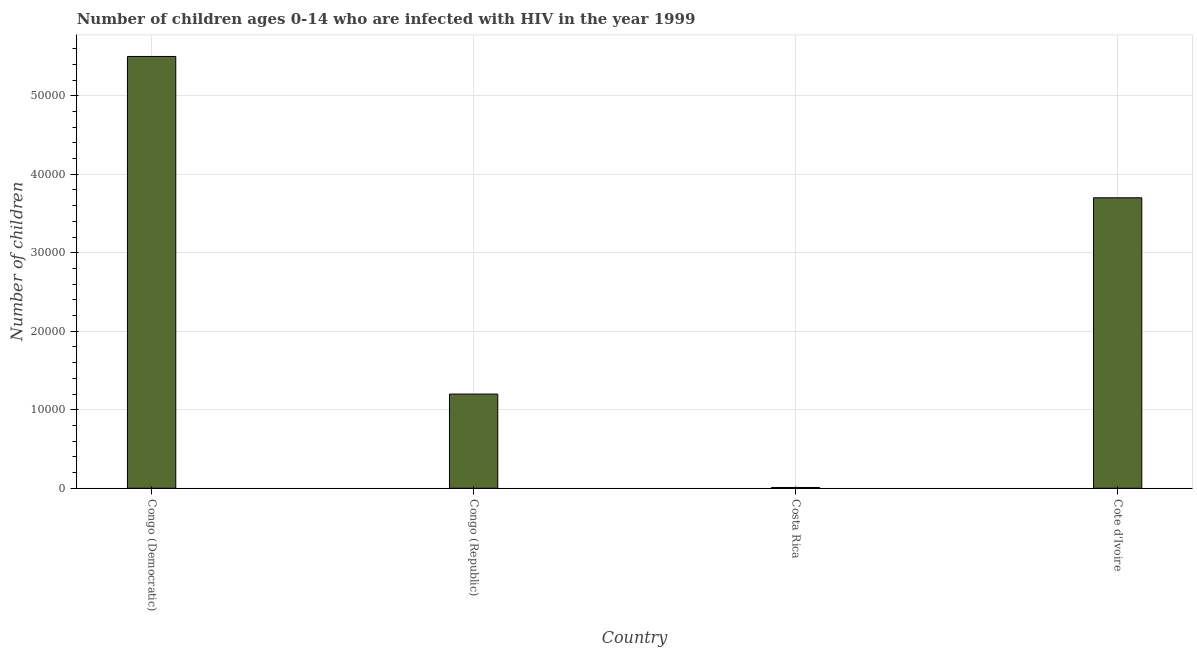Does the graph contain any zero values?
Make the answer very short. No. Does the graph contain grids?
Ensure brevity in your answer.  Yes. What is the title of the graph?
Give a very brief answer. Number of children ages 0-14 who are infected with HIV in the year 1999. What is the label or title of the Y-axis?
Offer a very short reply. Number of children. What is the number of children living with hiv in Cote d'Ivoire?
Your response must be concise. 3.70e+04. Across all countries, what is the maximum number of children living with hiv?
Keep it short and to the point. 5.50e+04. Across all countries, what is the minimum number of children living with hiv?
Provide a succinct answer. 100. In which country was the number of children living with hiv maximum?
Your response must be concise. Congo (Democratic). What is the sum of the number of children living with hiv?
Provide a succinct answer. 1.04e+05. What is the difference between the number of children living with hiv in Congo (Democratic) and Cote d'Ivoire?
Your answer should be compact. 1.80e+04. What is the average number of children living with hiv per country?
Offer a very short reply. 2.60e+04. What is the median number of children living with hiv?
Make the answer very short. 2.45e+04. In how many countries, is the number of children living with hiv greater than 48000 ?
Provide a short and direct response. 1. What is the ratio of the number of children living with hiv in Congo (Democratic) to that in Costa Rica?
Offer a very short reply. 550. What is the difference between the highest and the second highest number of children living with hiv?
Give a very brief answer. 1.80e+04. What is the difference between the highest and the lowest number of children living with hiv?
Your answer should be very brief. 5.49e+04. How many bars are there?
Your response must be concise. 4. Are the values on the major ticks of Y-axis written in scientific E-notation?
Keep it short and to the point. No. What is the Number of children in Congo (Democratic)?
Your answer should be compact. 5.50e+04. What is the Number of children of Congo (Republic)?
Your answer should be compact. 1.20e+04. What is the Number of children in Cote d'Ivoire?
Your answer should be very brief. 3.70e+04. What is the difference between the Number of children in Congo (Democratic) and Congo (Republic)?
Ensure brevity in your answer.  4.30e+04. What is the difference between the Number of children in Congo (Democratic) and Costa Rica?
Offer a terse response. 5.49e+04. What is the difference between the Number of children in Congo (Democratic) and Cote d'Ivoire?
Provide a short and direct response. 1.80e+04. What is the difference between the Number of children in Congo (Republic) and Costa Rica?
Your answer should be very brief. 1.19e+04. What is the difference between the Number of children in Congo (Republic) and Cote d'Ivoire?
Your answer should be very brief. -2.50e+04. What is the difference between the Number of children in Costa Rica and Cote d'Ivoire?
Make the answer very short. -3.69e+04. What is the ratio of the Number of children in Congo (Democratic) to that in Congo (Republic)?
Your response must be concise. 4.58. What is the ratio of the Number of children in Congo (Democratic) to that in Costa Rica?
Your response must be concise. 550. What is the ratio of the Number of children in Congo (Democratic) to that in Cote d'Ivoire?
Provide a succinct answer. 1.49. What is the ratio of the Number of children in Congo (Republic) to that in Costa Rica?
Your answer should be compact. 120. What is the ratio of the Number of children in Congo (Republic) to that in Cote d'Ivoire?
Provide a succinct answer. 0.32. What is the ratio of the Number of children in Costa Rica to that in Cote d'Ivoire?
Make the answer very short. 0. 